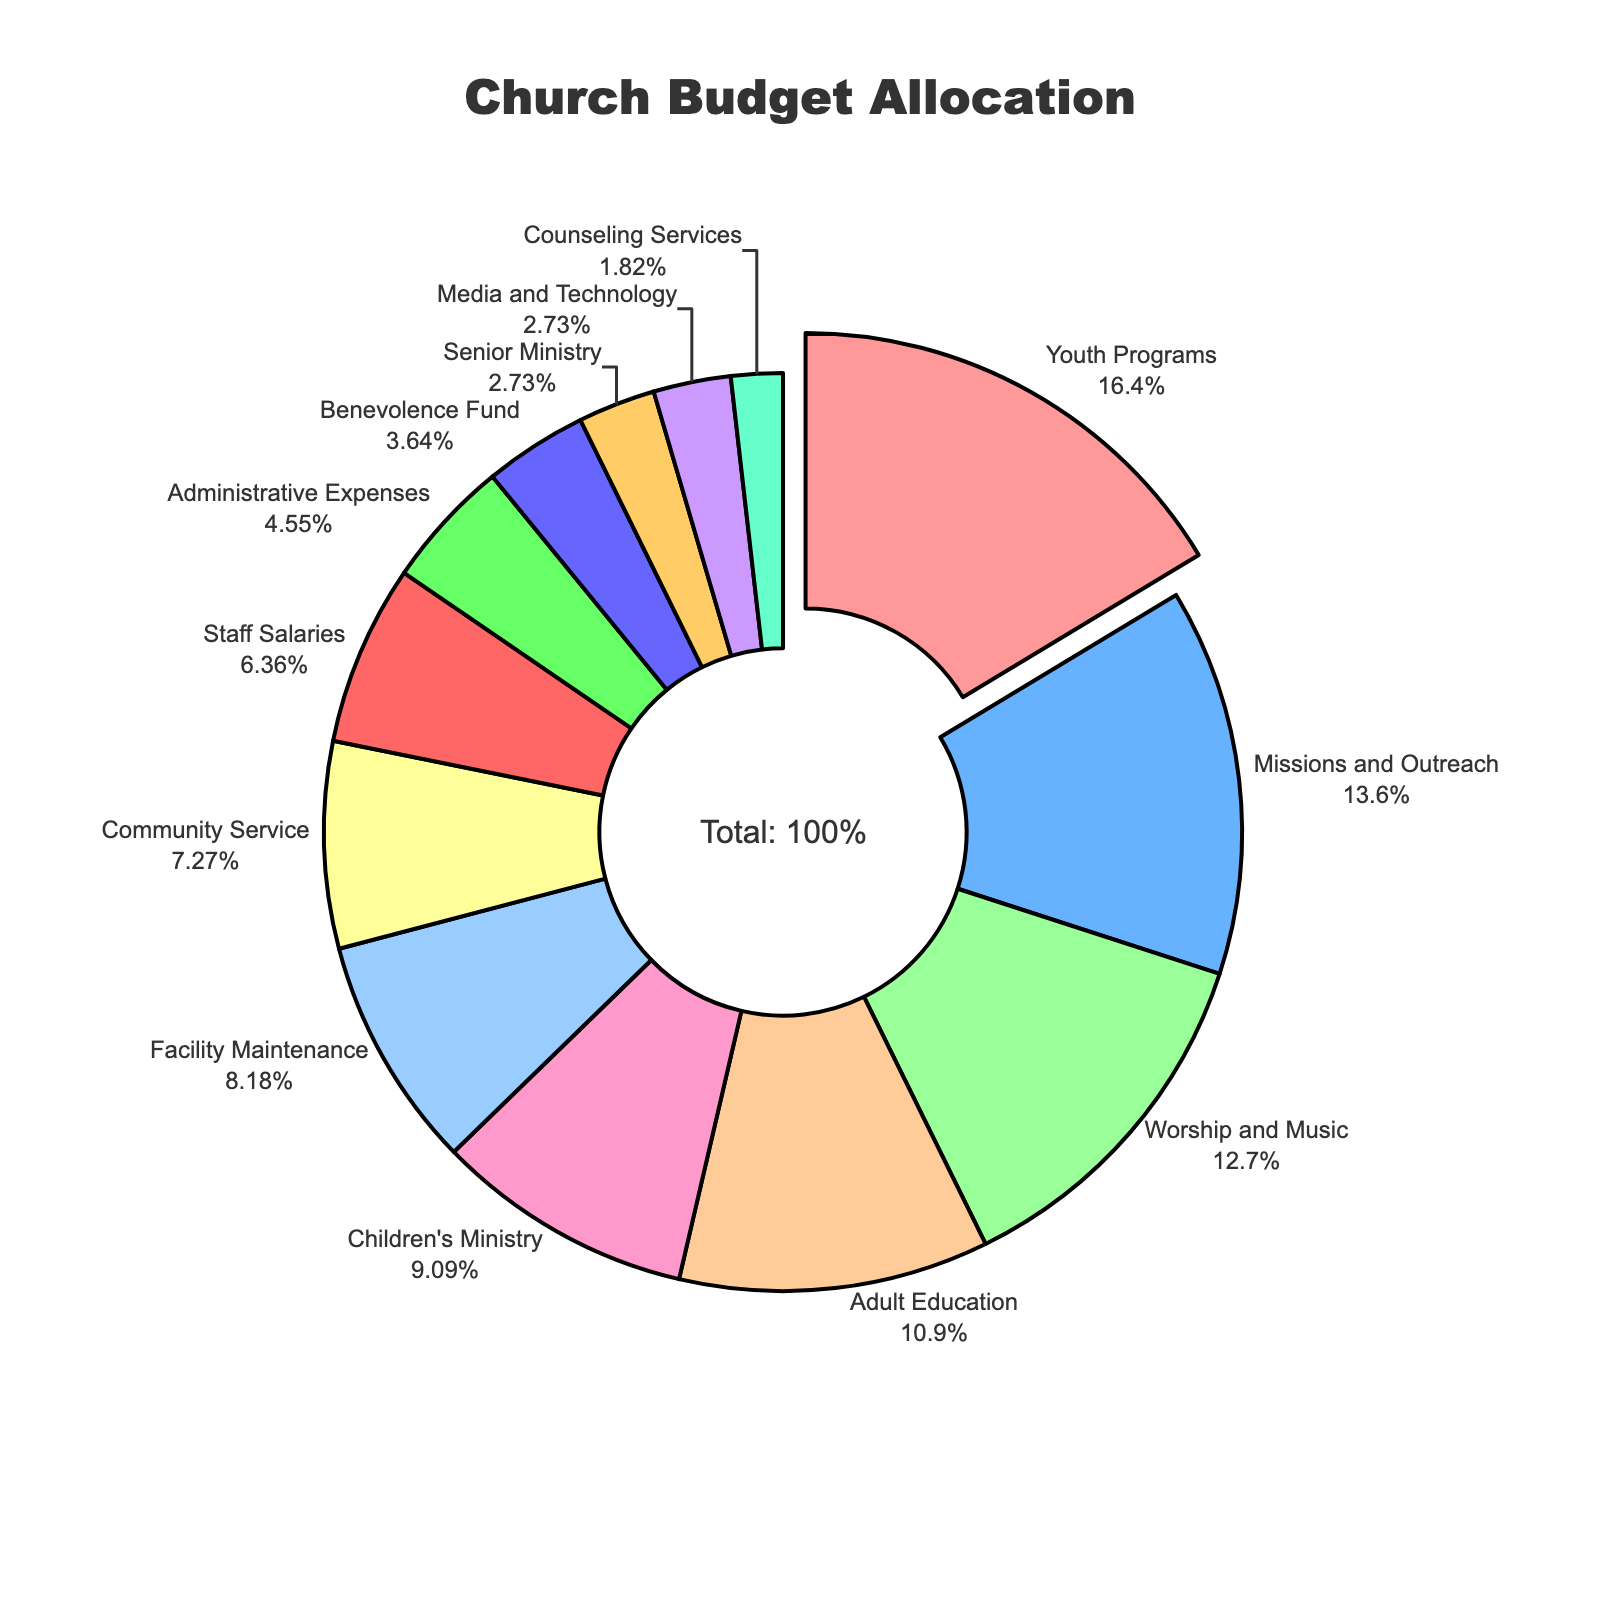Which ministry receives the highest percentage of the church budget? The pie chart has one segment pulled out for emphasis, which corresponds to the ministry receiving the highest percentage. In this case, "Youth Programs" is pulled out, indicating it has the highest allocation.
Answer: Youth Programs How much more budget is allocated to Youth Programs compared to Children’s Ministry? According to the chart, Youth Programs receive 18% of the budget while Children's Ministry gets 10%. The difference is 18% - 10%.
Answer: 8% What is the combined budget allocation percentage for Worship and Music, Administrative Expenses, and Benevolence Fund? Adding the percentages for Worship and Music (14%), Administrative Expenses (5%), and Benevolence Fund (4%) gives 14% + 5% + 4%.
Answer: 23% Among Adult Education, Facility Maintenance, and Administrative Expenses, which has the smallest budget allocation? According to the pie chart, Adult Education has 12%, Facility Maintenance has 9%, and Administrative Expenses has 5%. Thus, Administrative Expenses are the smallest.
Answer: Administrative Expenses Are Media and Technology, Counseling Services, and Senior Ministry each allocated less than 5% of the budget? The pie chart shows Media and Technology at 3%, Counseling Services at 2%, and Senior Ministry at 3%. Each of these is less than 5%.
Answer: Yes What percentage of the budget is allocated to programs related to different age groups: Youth Programs, Children’s Ministry, and Senior Ministry combined? Summing the percentages for Youth Programs (18%), Children's Ministry (10%), and Senior Ministry (3%) gives 18% + 10% + 3%.
Answer: 31% Which programs receive a higher budget allocation than Missions and Outreach? According to the pie chart, the percentages for Missions and Outreach (15%) are less than those for Youth Programs (18%). Thus, only Youth Programs receive a higher allocation.
Answer: Youth Programs How does the allocation for Facility Maintenance compare to that for Community Service? Facility Maintenance is allocated 9% of the budget, while Community Service gets 8%. Thus, Facility Maintenance has a higher percentage.
Answer: Facility Maintenance has a higher percentage What is the visual indication that the ministry with the highest budget allocation stands out in the pie chart? The segment for the ministry with the highest budget allocation, Youth Programs, is pulled out from the pie chart for emphasis.
Answer: Pulled out Comparing the allocation percentages for Staff Salaries and Benevolence Fund, which one is larger and by how much? Staff Salaries receive 7% of the budget and Benevolence Fund gets 4%. The difference is 7% - 4%.
Answer: Staff Salaries, by 3% 